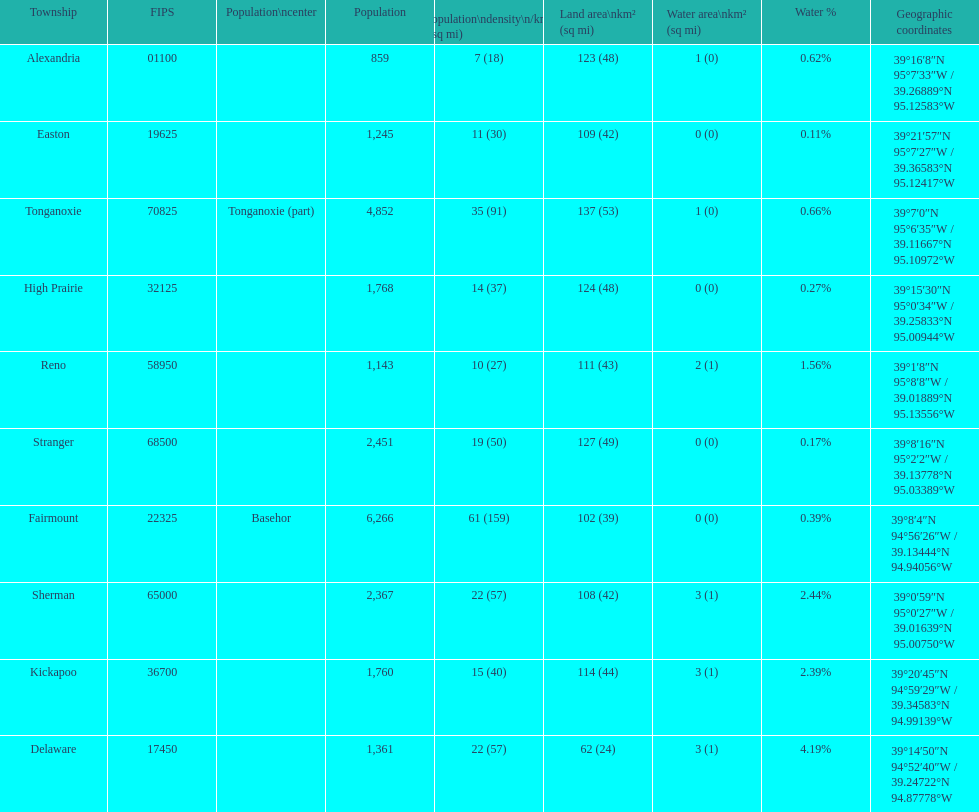How many townships have populations over 2,000? 4. 